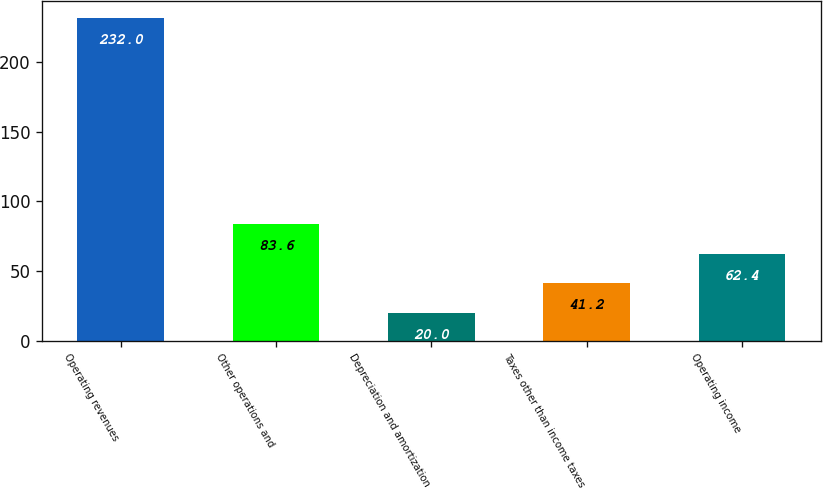Convert chart to OTSL. <chart><loc_0><loc_0><loc_500><loc_500><bar_chart><fcel>Operating revenues<fcel>Other operations and<fcel>Depreciation and amortization<fcel>Taxes other than income taxes<fcel>Operating income<nl><fcel>232<fcel>83.6<fcel>20<fcel>41.2<fcel>62.4<nl></chart> 